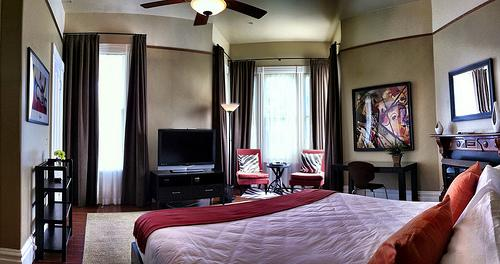Question: what is the picture of?
Choices:
A. Bathroom.
B. Living room.
C. Classroom.
D. Bedroom.
Answer with the letter. Answer: D Question: when was it taken?
Choices:
A. Last night.
B. Daytime.
C. Today.
D. Yesterday.
Answer with the letter. Answer: B Question: where was this photo shot?
Choices:
A. At the beach.
B. At the zoo.
C. Disney World.
D. Bedroom.
Answer with the letter. Answer: D 